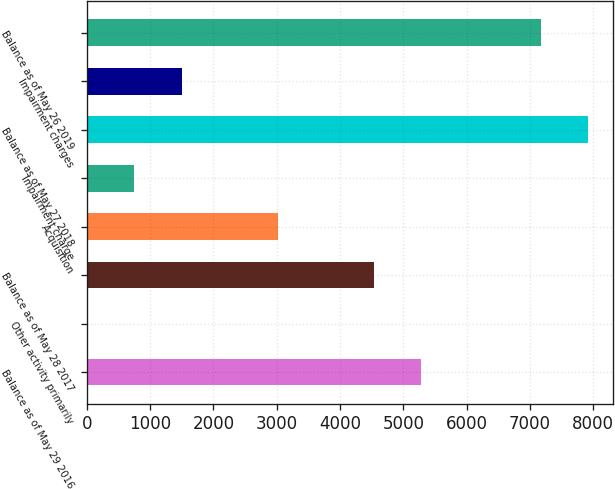Convert chart. <chart><loc_0><loc_0><loc_500><loc_500><bar_chart><fcel>Balance as of May 29 2016<fcel>Other activity primarily<fcel>Balance as of May 28 2017<fcel>Acquisition<fcel>Impairment charge<fcel>Balance as of May 27 2018<fcel>Impairment charges<fcel>Balance as of May 26 2019<nl><fcel>5274.09<fcel>8.2<fcel>4530.4<fcel>3015<fcel>751.89<fcel>7910.49<fcel>1495.58<fcel>7166.8<nl></chart> 